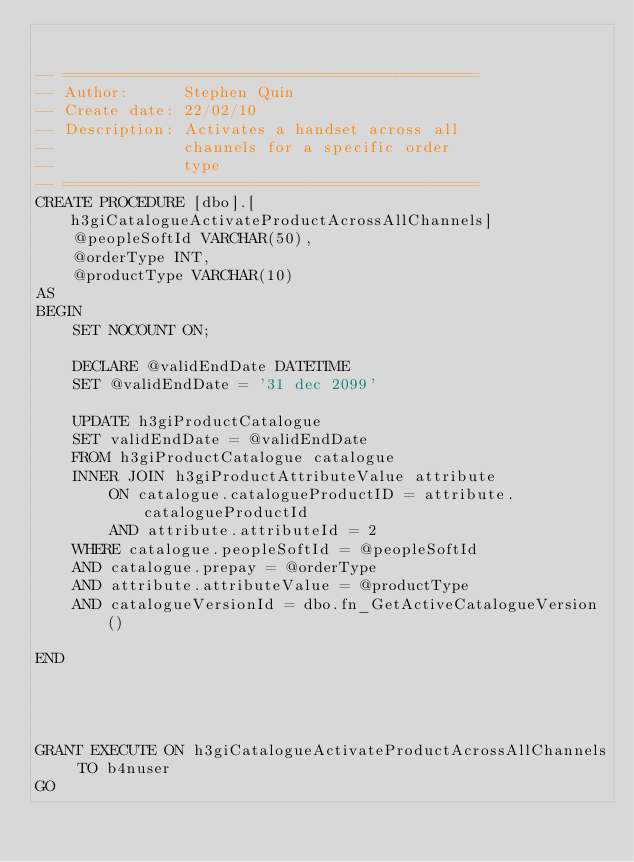<code> <loc_0><loc_0><loc_500><loc_500><_SQL_>

-- =============================================
-- Author:		Stephen Quin
-- Create date: 22/02/10
-- Description:	Activates a handset across all
--				channels for a specific order
--				type
-- =============================================
CREATE PROCEDURE [dbo].[h3giCatalogueActivateProductAcrossAllChannels]
	@peopleSoftId VARCHAR(50),
	@orderType INT,
	@productType VARCHAR(10)
AS
BEGIN
	SET NOCOUNT ON;

	DECLARE @validEndDate DATETIME
	SET @validEndDate = '31 dec 2099'
	
	UPDATE h3giProductCatalogue 
	SET validEndDate = @validEndDate
	FROM h3giProductCatalogue catalogue
    INNER JOIN h3giProductAttributeValue attribute
		ON catalogue.catalogueProductID = attribute.catalogueProductId
		AND attribute.attributeId = 2
	WHERE catalogue.peopleSoftId = @peopleSoftId
	AND catalogue.prepay = @orderType
	AND attribute.attributeValue = @productType
	AND catalogueVersionId = dbo.fn_GetActiveCatalogueVersion()

END




GRANT EXECUTE ON h3giCatalogueActivateProductAcrossAllChannels TO b4nuser
GO
</code> 